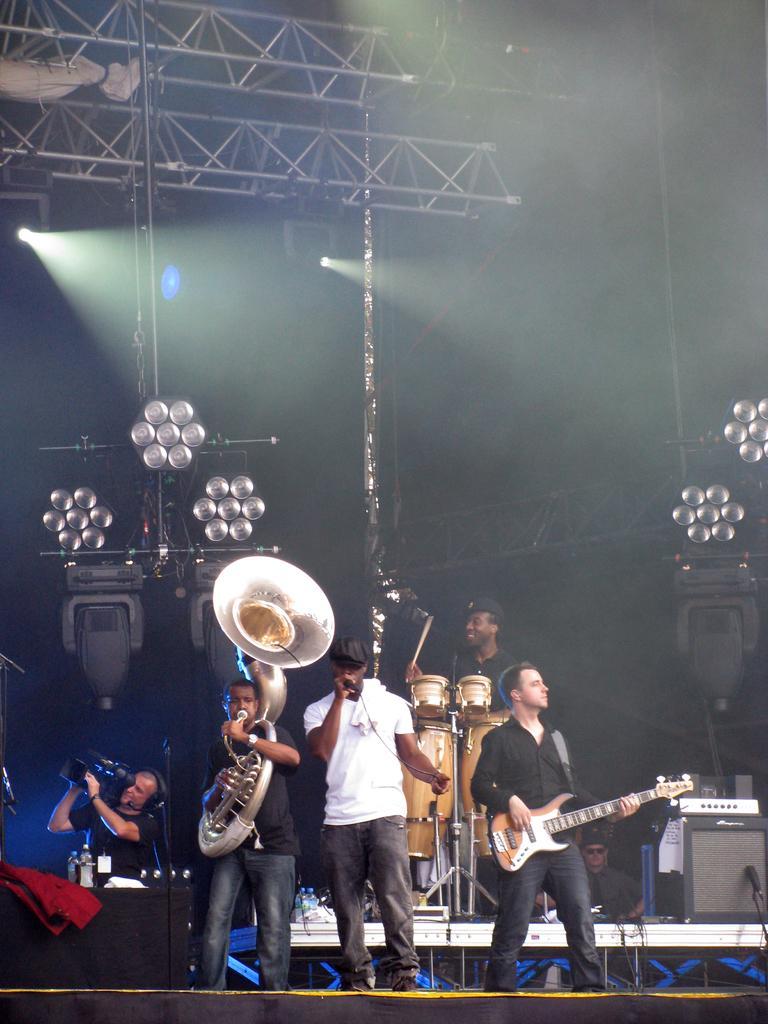Please provide a concise description of this image. this picture show a group of people performing and playing musical instrument and here we see a man recording with a video camera. 